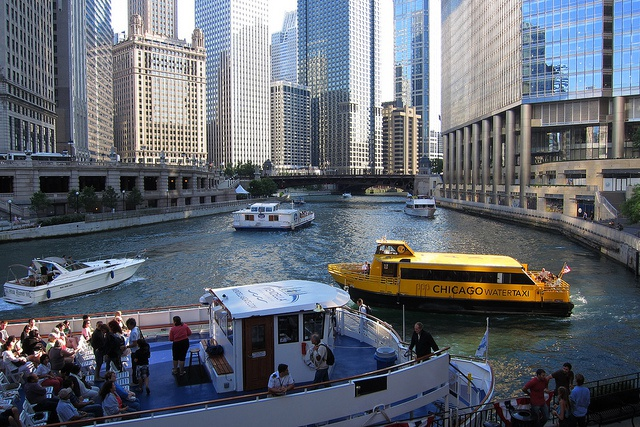Describe the objects in this image and their specific colors. I can see boat in gray, black, and navy tones, people in gray, black, navy, and darkgray tones, boat in gray, black, olive, and khaki tones, boat in gray, darkgray, and black tones, and boat in gray and darkgray tones in this image. 